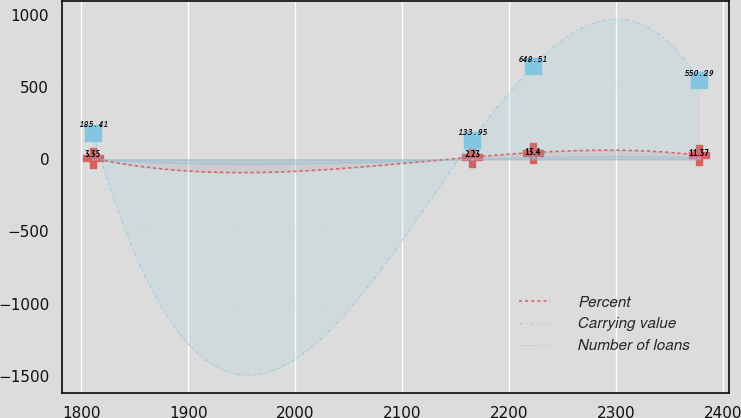Convert chart. <chart><loc_0><loc_0><loc_500><loc_500><line_chart><ecel><fcel>Percent<fcel>Carrying value<fcel>Number of loans<nl><fcel>1810.79<fcel>7.27<fcel>185.41<fcel>3.35<nl><fcel>2165.34<fcel>15.41<fcel>133.95<fcel>2.23<nl><fcel>2221.96<fcel>46.72<fcel>648.51<fcel>13.4<nl><fcel>2377.03<fcel>28.98<fcel>550.29<fcel>11.37<nl></chart> 